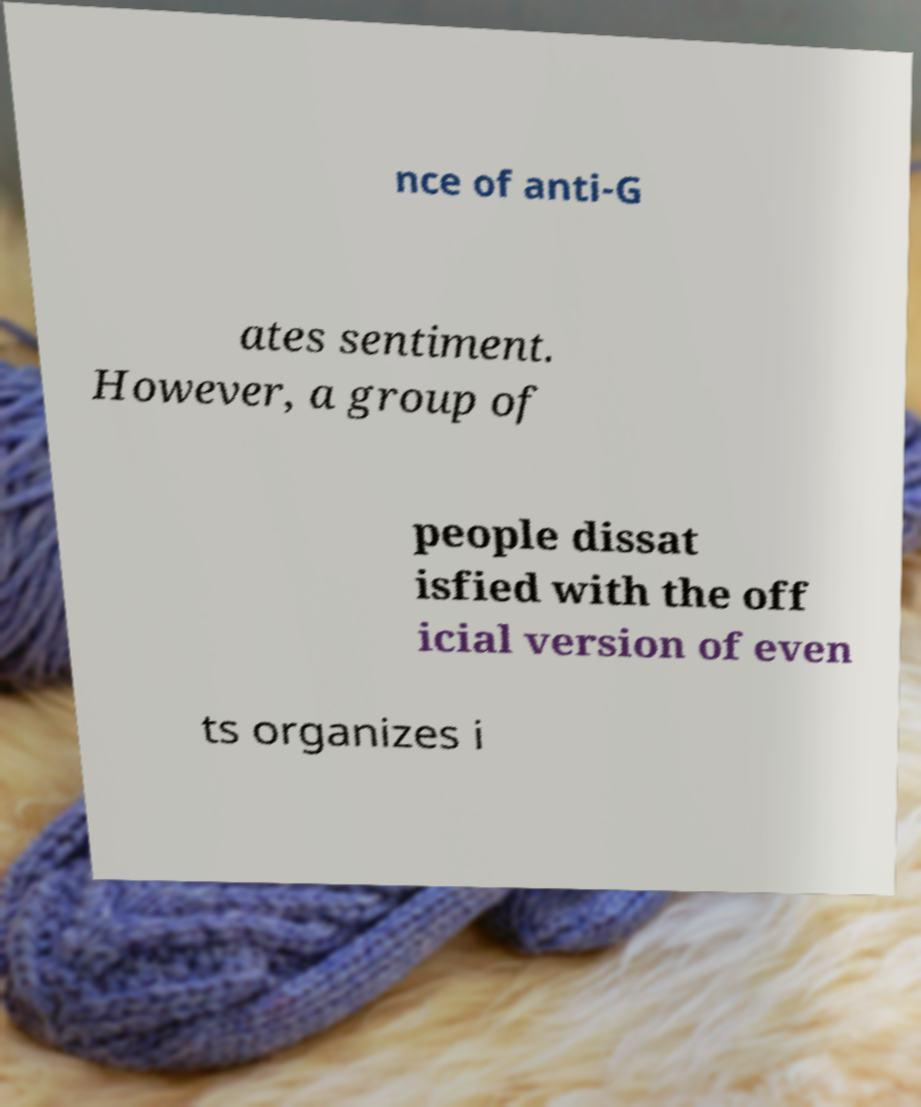I need the written content from this picture converted into text. Can you do that? nce of anti-G ates sentiment. However, a group of people dissat isfied with the off icial version of even ts organizes i 